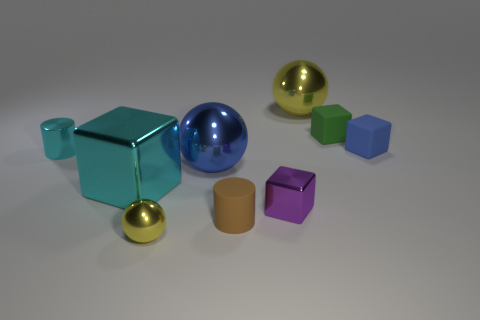Subtract all small cubes. How many cubes are left? 1 Subtract all purple cylinders. How many yellow spheres are left? 2 Subtract 3 blocks. How many blocks are left? 1 Subtract all yellow balls. How many balls are left? 1 Subtract all brown balls. Subtract all brown cylinders. How many balls are left? 3 Subtract all big red cubes. Subtract all large blue spheres. How many objects are left? 8 Add 4 tiny blue blocks. How many tiny blue blocks are left? 5 Add 8 large blue rubber cubes. How many large blue rubber cubes exist? 8 Subtract 0 purple cylinders. How many objects are left? 9 Subtract all cylinders. How many objects are left? 7 